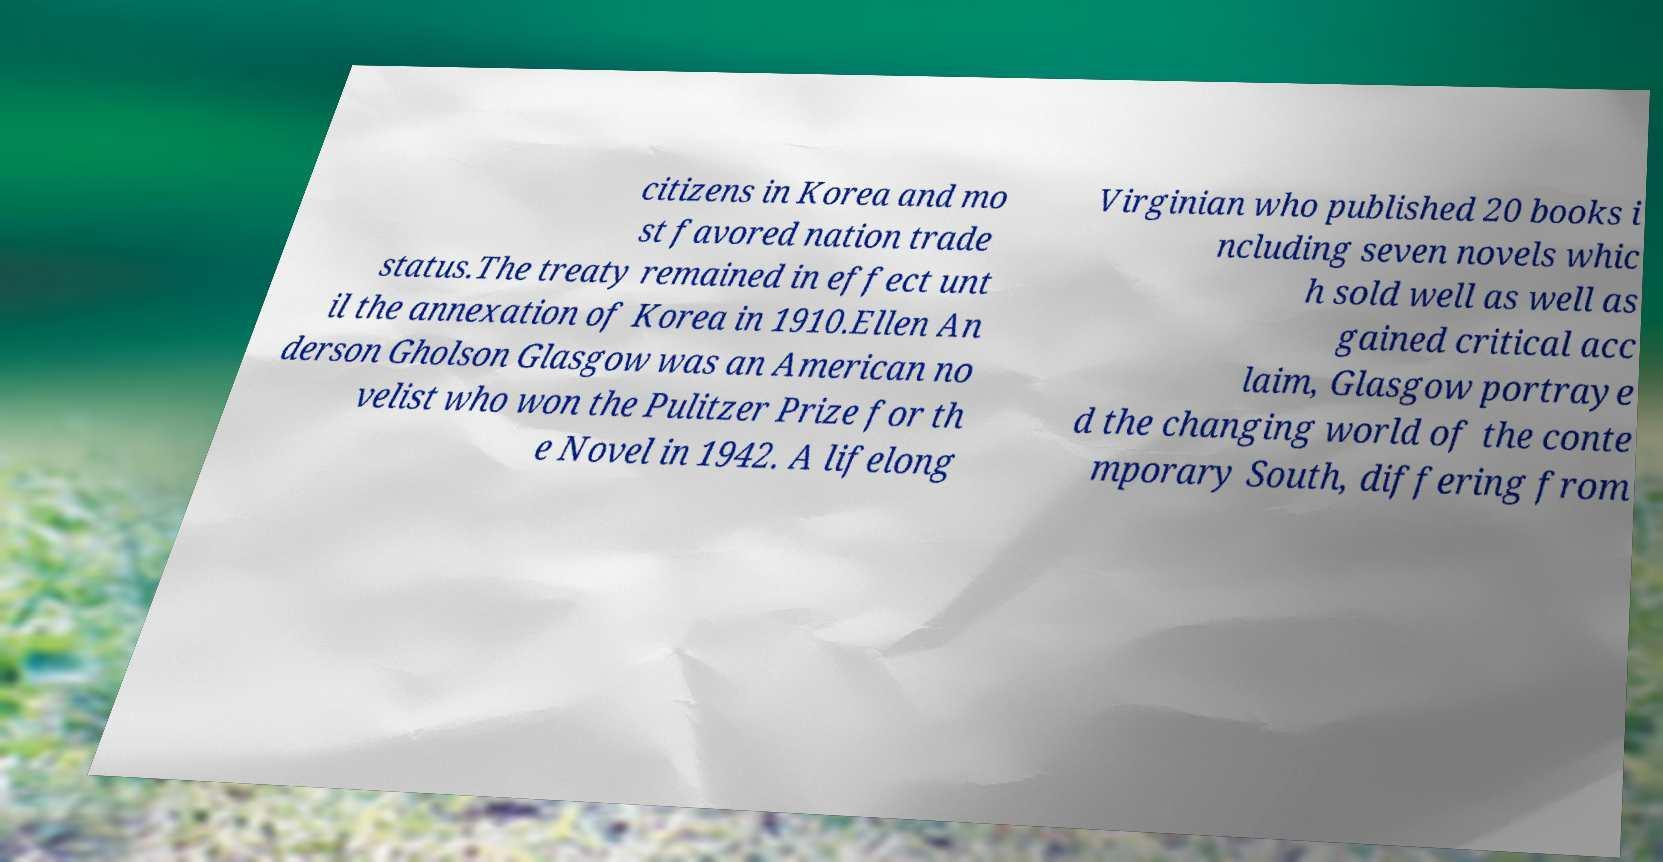I need the written content from this picture converted into text. Can you do that? citizens in Korea and mo st favored nation trade status.The treaty remained in effect unt il the annexation of Korea in 1910.Ellen An derson Gholson Glasgow was an American no velist who won the Pulitzer Prize for th e Novel in 1942. A lifelong Virginian who published 20 books i ncluding seven novels whic h sold well as well as gained critical acc laim, Glasgow portraye d the changing world of the conte mporary South, differing from 